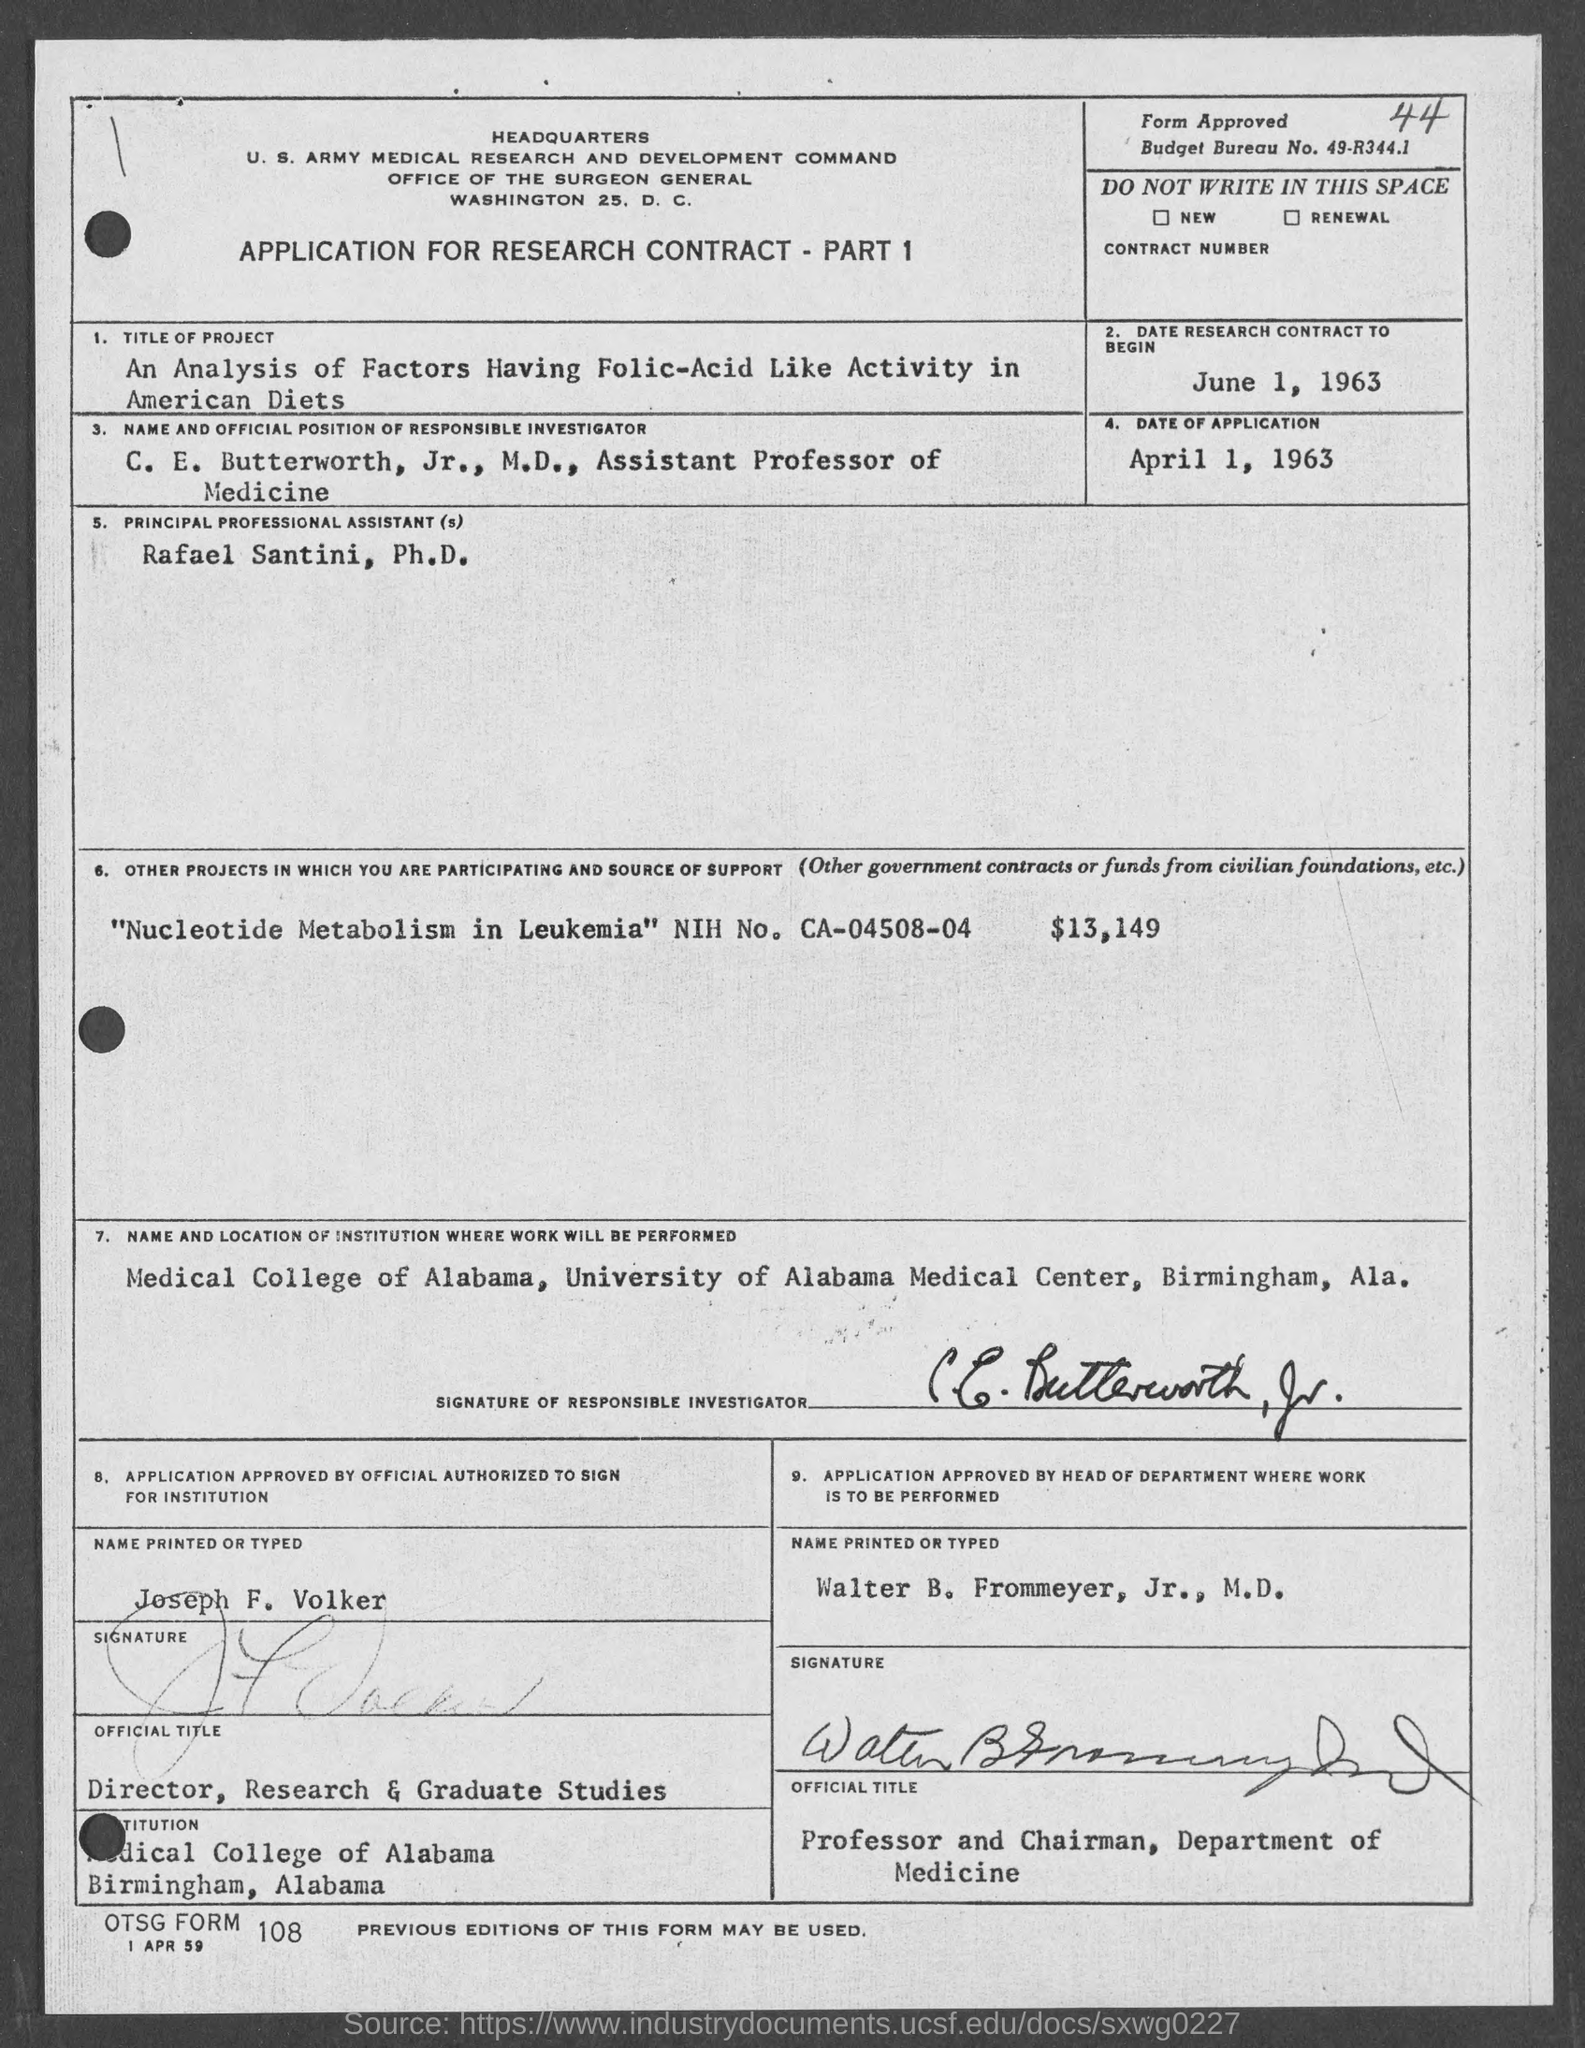Specify some key components in this picture. The date of the application is April 1, 1963. The research contract will commence on June 1, 1963. Rafael Santini is the principal professional assistant. The Budget Bureau Number is 49-R344.1... 